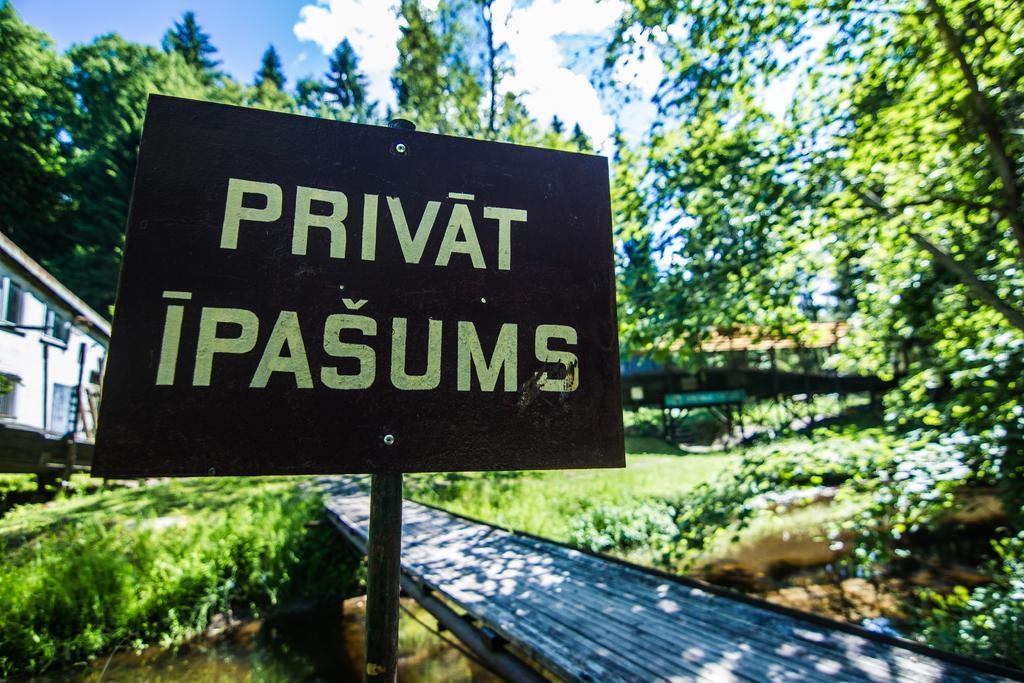How would you summarize this image in a sentence or two? Here I can see a board on which I can see some text. At the bottom of the image I can see some water, on that there is a bridge. In the background there are some houses and trees and also I can see a shed. On the top of the image I can see the sky and clouds. 